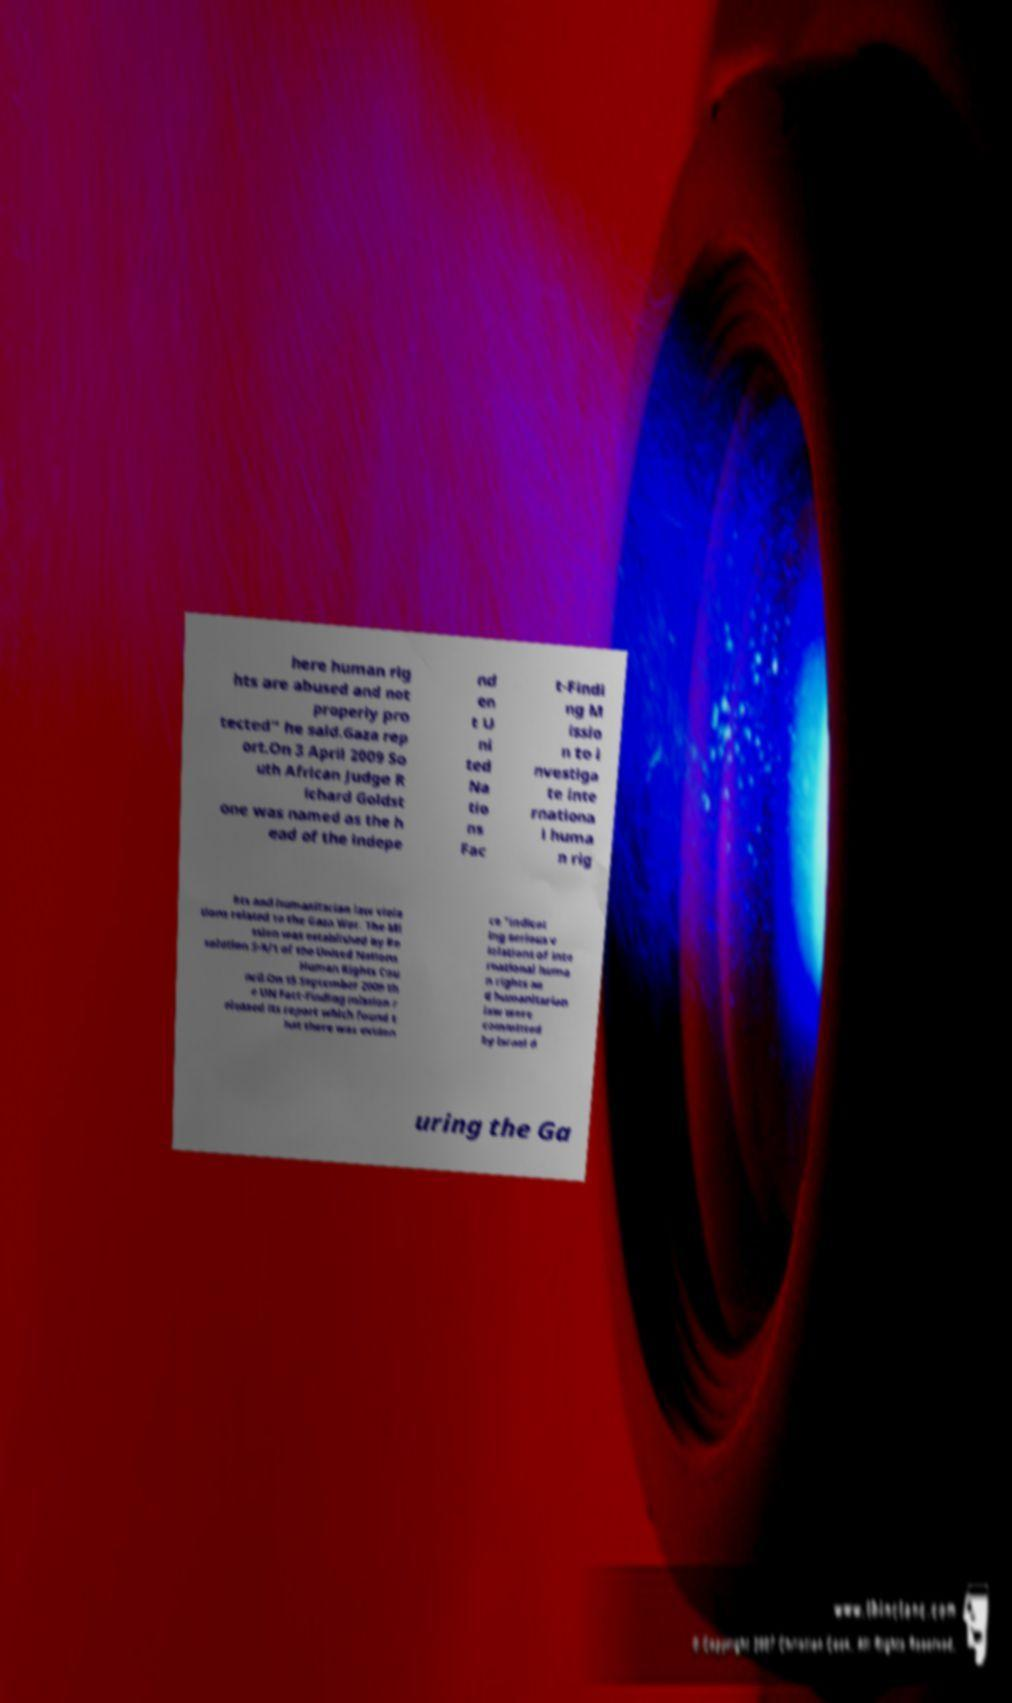Could you extract and type out the text from this image? here human rig hts are abused and not properly pro tected" he said.Gaza rep ort.On 3 April 2009 So uth African Judge R ichard Goldst one was named as the h ead of the indepe nd en t U ni ted Na tio ns Fac t-Findi ng M issio n to i nvestiga te inte rnationa l huma n rig hts and humanitarian law viola tions related to the Gaza War. The Mi ssion was established by Re solution S-9/1 of the United Nations Human Rights Cou ncil.On 15 September 2009 th e UN Fact-Finding mission r eleased its report which found t hat there was eviden ce "indicat ing serious v iolations of inte rnational huma n rights an d humanitarian law were committed by Israel d uring the Ga 